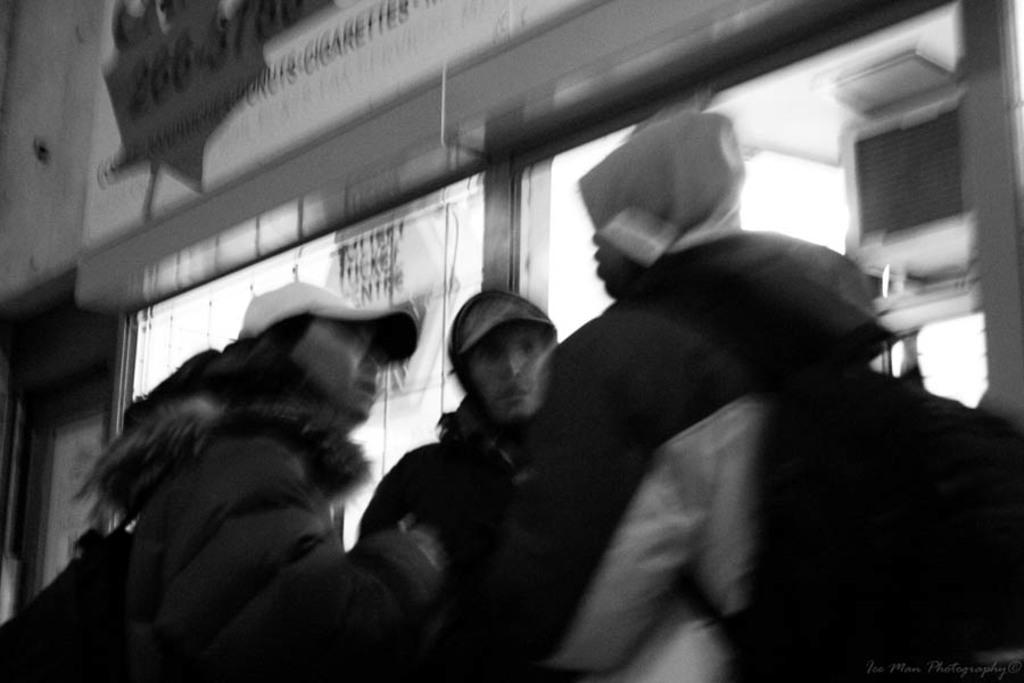Who or what is present in the picture? There are people in the picture. What are the people wearing on their heads? The people are wearing hats. What is the color scheme of the picture? The picture is black and white in color. What type of canvas is the man painting in the image? There is no man painting a canvas in the image; the people are wearing hats and the picture is black and white. 